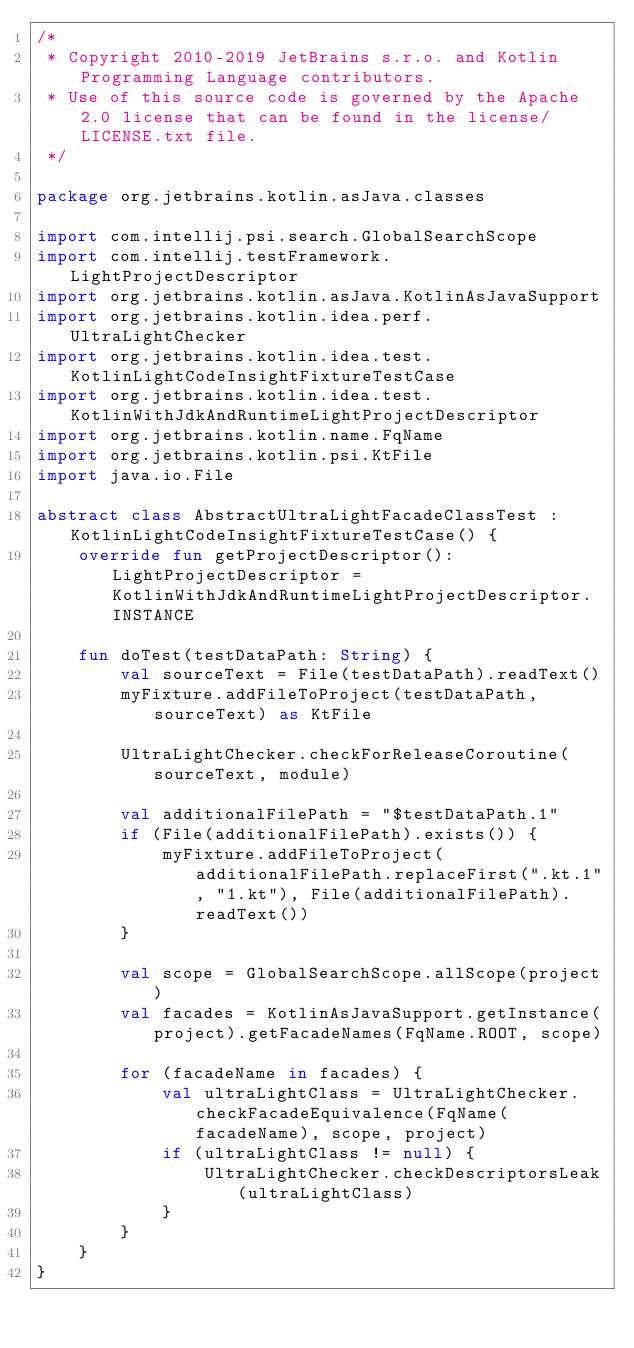<code> <loc_0><loc_0><loc_500><loc_500><_Kotlin_>/*
 * Copyright 2010-2019 JetBrains s.r.o. and Kotlin Programming Language contributors.
 * Use of this source code is governed by the Apache 2.0 license that can be found in the license/LICENSE.txt file.
 */

package org.jetbrains.kotlin.asJava.classes

import com.intellij.psi.search.GlobalSearchScope
import com.intellij.testFramework.LightProjectDescriptor
import org.jetbrains.kotlin.asJava.KotlinAsJavaSupport
import org.jetbrains.kotlin.idea.perf.UltraLightChecker
import org.jetbrains.kotlin.idea.test.KotlinLightCodeInsightFixtureTestCase
import org.jetbrains.kotlin.idea.test.KotlinWithJdkAndRuntimeLightProjectDescriptor
import org.jetbrains.kotlin.name.FqName
import org.jetbrains.kotlin.psi.KtFile
import java.io.File

abstract class AbstractUltraLightFacadeClassTest : KotlinLightCodeInsightFixtureTestCase() {
    override fun getProjectDescriptor(): LightProjectDescriptor = KotlinWithJdkAndRuntimeLightProjectDescriptor.INSTANCE

    fun doTest(testDataPath: String) {
        val sourceText = File(testDataPath).readText()
        myFixture.addFileToProject(testDataPath, sourceText) as KtFile

        UltraLightChecker.checkForReleaseCoroutine(sourceText, module)

        val additionalFilePath = "$testDataPath.1"
        if (File(additionalFilePath).exists()) {
            myFixture.addFileToProject(additionalFilePath.replaceFirst(".kt.1", "1.kt"), File(additionalFilePath).readText())
        }

        val scope = GlobalSearchScope.allScope(project)
        val facades = KotlinAsJavaSupport.getInstance(project).getFacadeNames(FqName.ROOT, scope)

        for (facadeName in facades) {
            val ultraLightClass = UltraLightChecker.checkFacadeEquivalence(FqName(facadeName), scope, project)
            if (ultraLightClass != null) {
                UltraLightChecker.checkDescriptorsLeak(ultraLightClass)
            }
        }
    }
}
</code> 